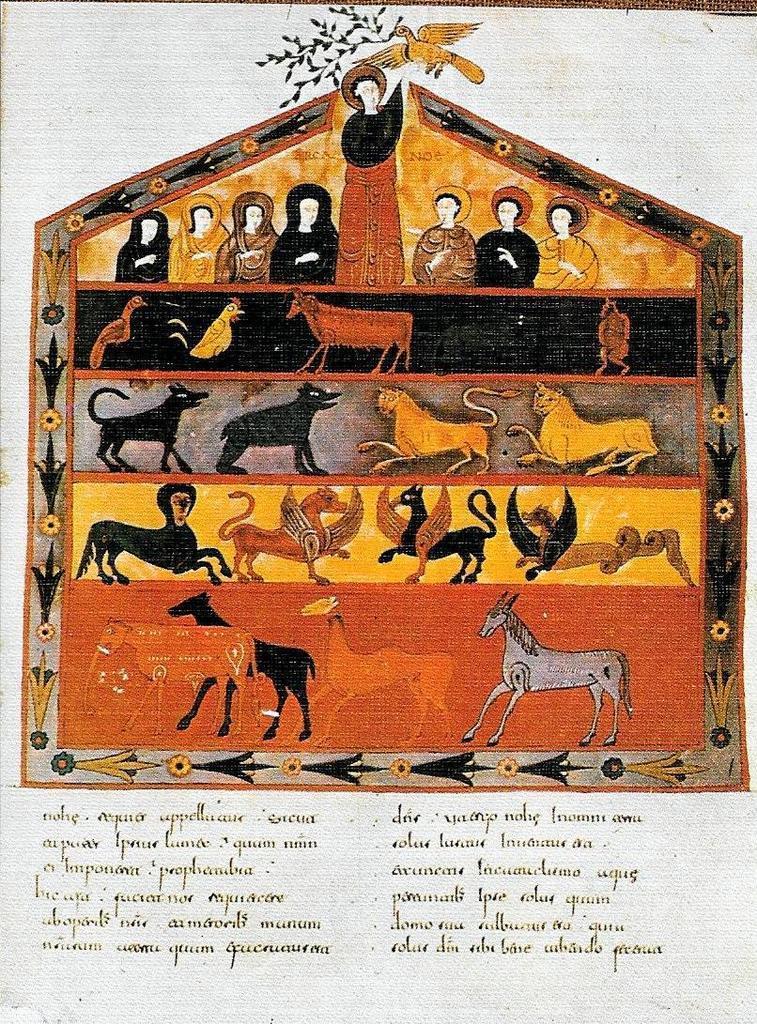In one or two sentences, can you explain what this image depicts? There is a poster having paintings of animals, a bird, persons and there are texts. And the background of this poster is white in color. 